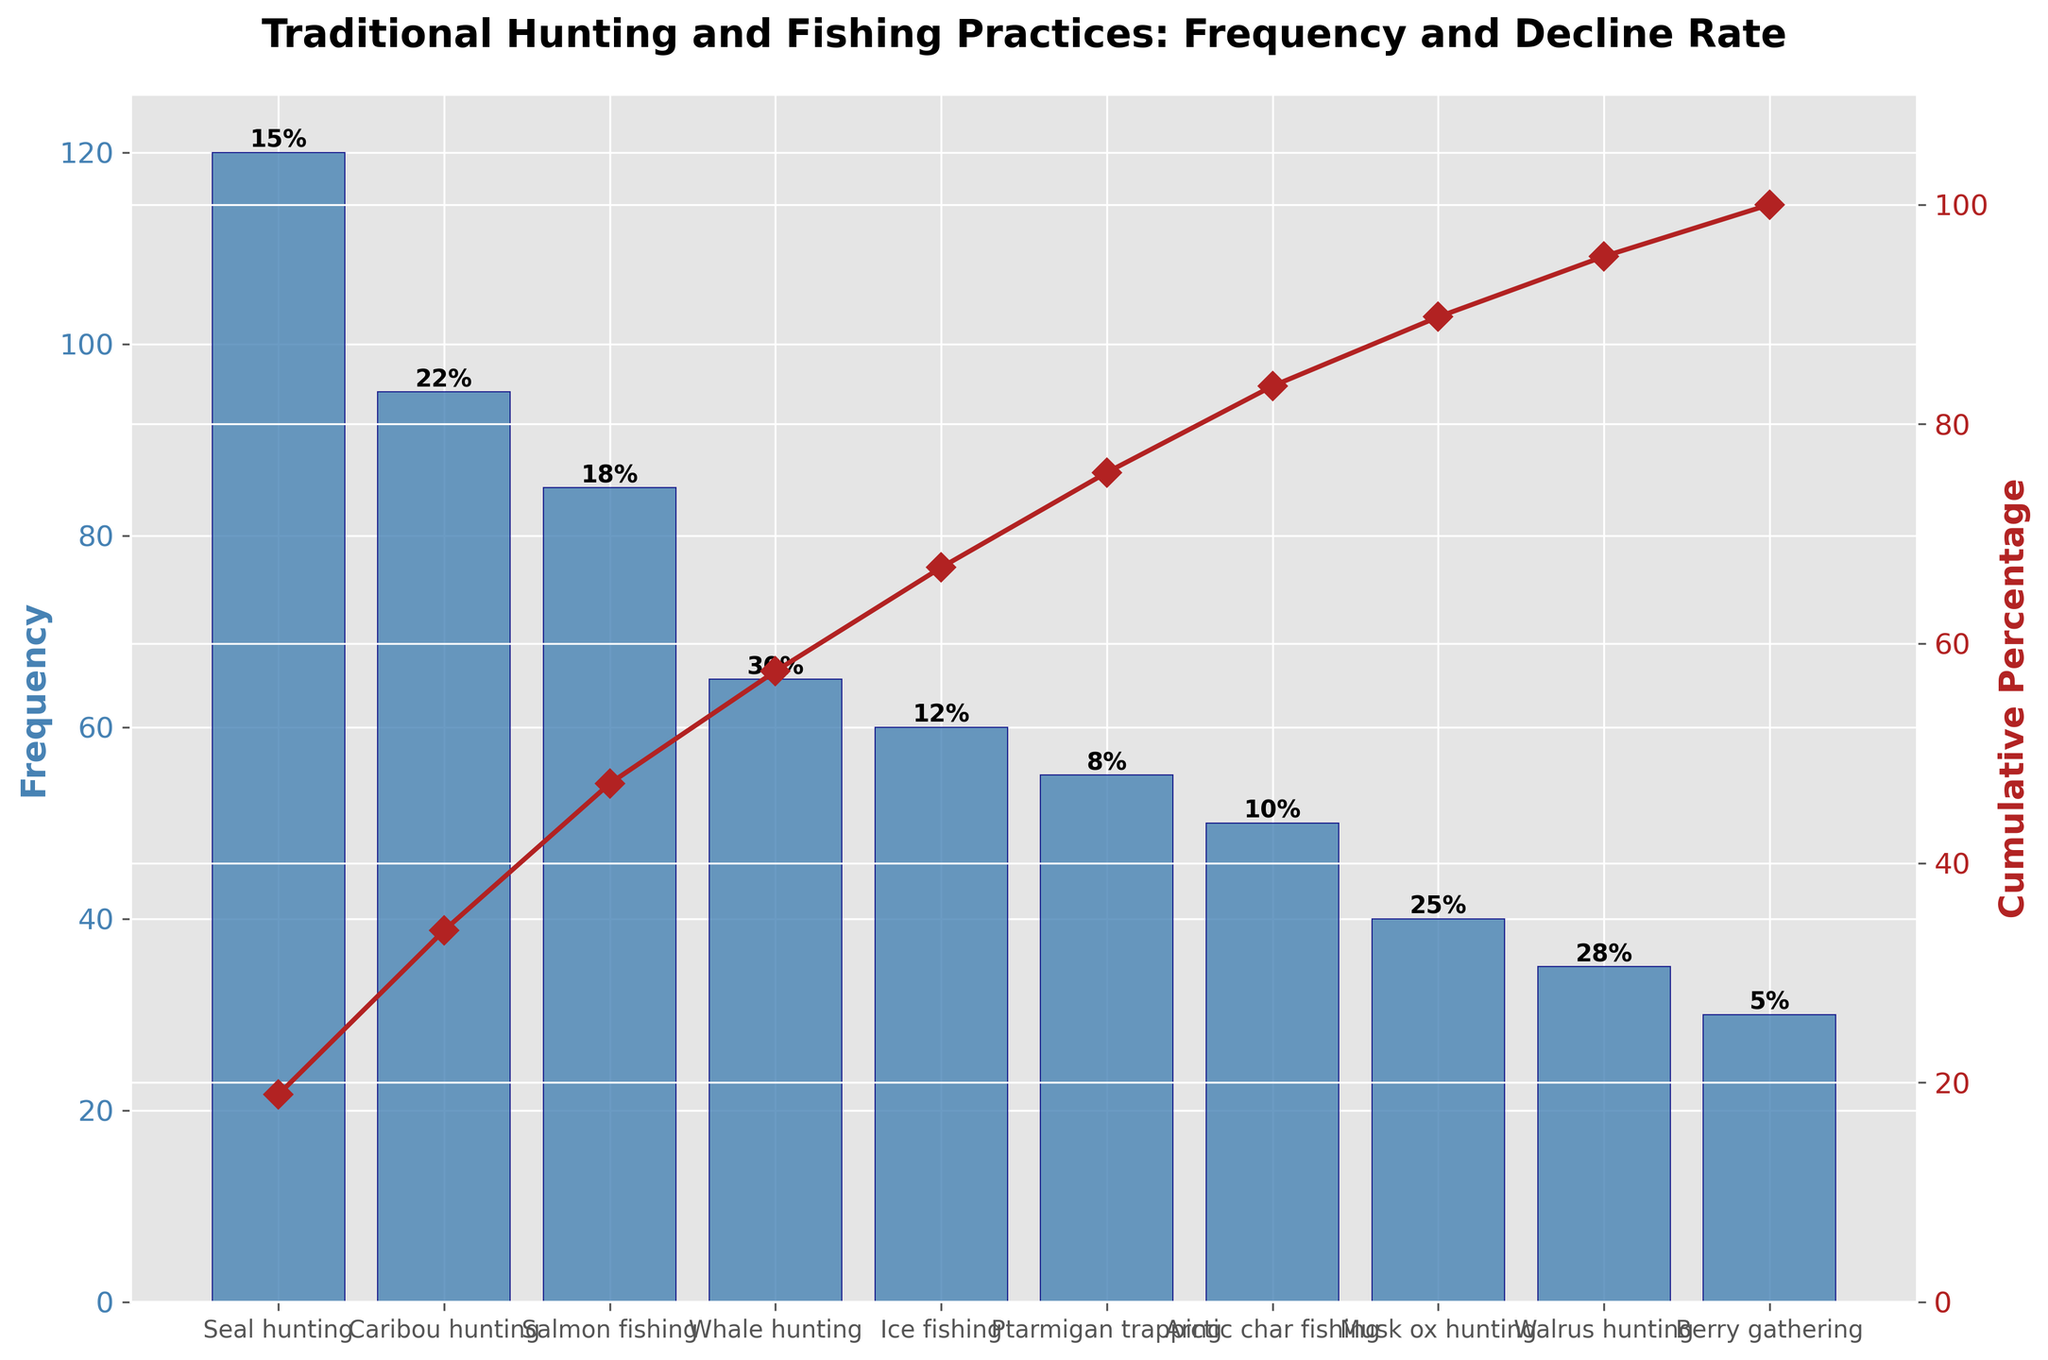What's the title of the chart? The title of the chart is displayed at the top in bold text.
Answer: Traditional Hunting and Fishing Practices: Frequency and Decline Rate How many practices are depicted in the chart? Each bar in the bar chart represents a practice.
Answer: 10 Which practice is the most frequently used? The practice with the tallest bar represents the most frequent practice.
Answer: Seal hunting What is the cumulative percentage after including Caribou hunting? We need to add the frequency of Seal hunting and Caribou hunting, then calculate their cumulative percentage. Seal hunting (120) + Caribou hunting (95) = 215. The total frequency sum = 635. So, (215 / 635) * 100 ≈ 33.86%.
Answer: Approximately 33.86% What is the decline rate of Whale hunting? The decline rate for each practice is shown as text above each bar.
Answer: 30% Which practice has the smallest decline rate? The practice with the smallest percentage text above its bar has the smallest decline rate.
Answer: Berry gathering Which practice has a higher decline rate: Musk ox hunting or Walrus hunting? Compare the decline rates indicated above the bars for Musk ox hunting and Walrus hunting.
Answer: Walrus hunting What are the frequencies of practices that have a decline rate higher than 20%? Identify the bars with a decline rate above 20%, and look at the frequencies of those practices.
Answer: Caribou hunting (95), Whale hunting (65), Musk ox hunting (40), Walrus hunting (35) Among the top three most frequently practiced activities, which one has the highest decline rate? The top three practices by frequency are Seal hunting, Caribou hunting, and Salmon fishing. Compare their decline rates.
Answer: Caribou hunting What percentage of the total practices do the four least frequent practices account for? Sum frequencies of Arctic char fishing (50), Musk ox hunting (40), Walrus hunting (35), Berry gathering (30) = 155, and then calculate their percentage of total frequency sum (635). (155 / 635) * 100 ≈ 24.41%.
Answer: Approximately 24.41% 